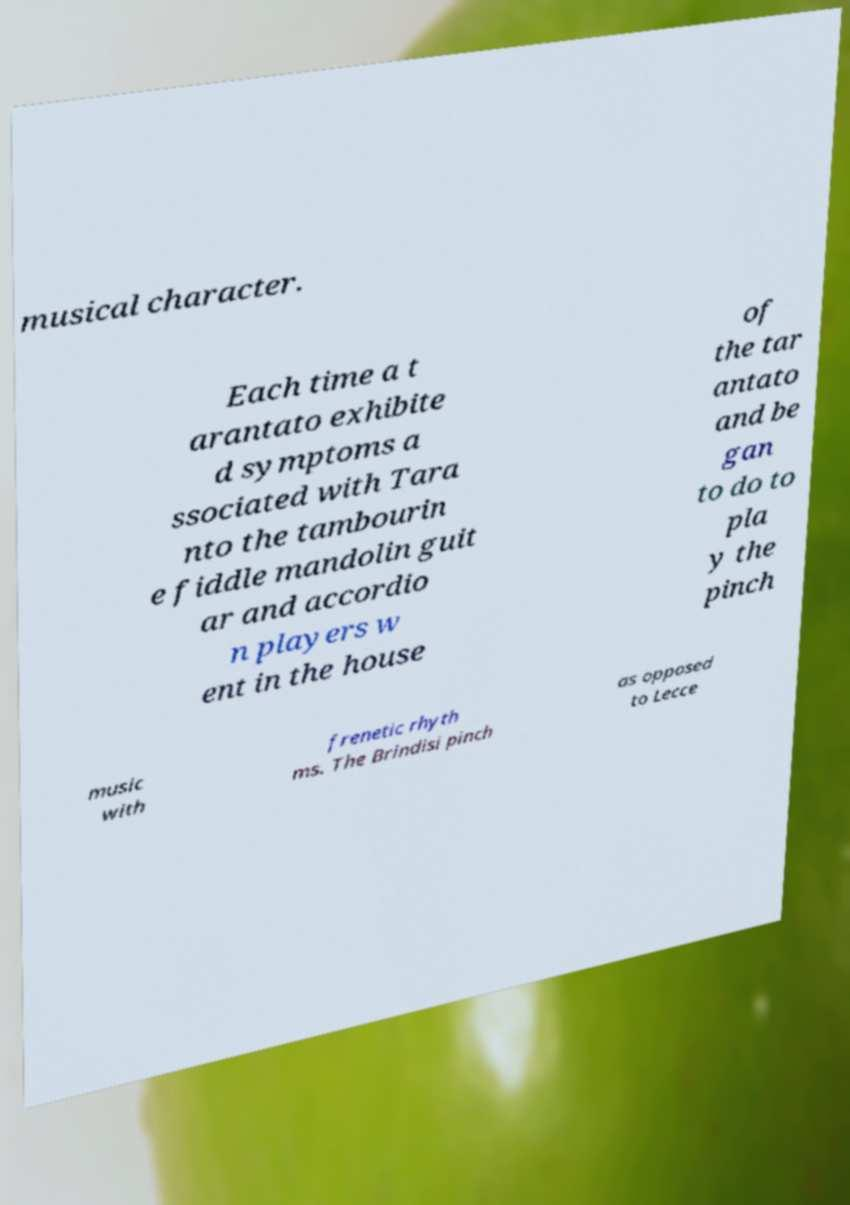Please identify and transcribe the text found in this image. musical character. Each time a t arantato exhibite d symptoms a ssociated with Tara nto the tambourin e fiddle mandolin guit ar and accordio n players w ent in the house of the tar antato and be gan to do to pla y the pinch music with frenetic rhyth ms. The Brindisi pinch as opposed to Lecce 